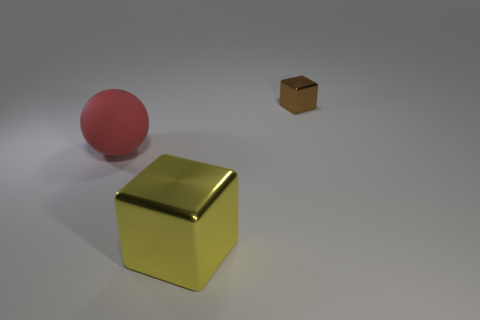Does the big red sphere have the same material as the large yellow block?
Your answer should be very brief. No. What number of blocks are either large red things or small brown shiny objects?
Make the answer very short. 1. There is a thing right of the metal thing that is in front of the cube that is right of the yellow metal cube; how big is it?
Your answer should be compact. Small. There is a brown object that is the same shape as the yellow metallic object; what is its size?
Give a very brief answer. Small. How many yellow things are right of the tiny cube?
Ensure brevity in your answer.  0. Is the color of the cube left of the tiny shiny thing the same as the large ball?
Your answer should be compact. No. What number of cyan things are big metal things or small cubes?
Ensure brevity in your answer.  0. There is a large object that is behind the metallic object in front of the big red rubber ball; what color is it?
Ensure brevity in your answer.  Red. The block behind the yellow thing is what color?
Keep it short and to the point. Brown. Is the size of the cube behind the red sphere the same as the red rubber thing?
Make the answer very short. No. 